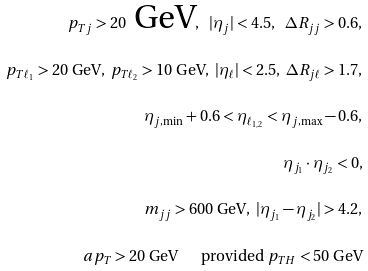<formula> <loc_0><loc_0><loc_500><loc_500>p _ { T j } > 2 0 \text { GeV} , \ | \eta _ { j } | < 4 . 5 , \ \Delta R _ { j j } > 0 . 6 , \\ p _ { T \ell _ { 1 } } > 2 0 \text { GeV} , \ p _ { T \ell _ { 2 } } > 1 0 \text { GeV} , \ | \eta _ { \ell } | < 2 . 5 , \ \Delta R _ { j \ell } > 1 . 7 , \\ \eta _ { j , \min } + 0 . 6 < \eta _ { \ell _ { 1 , 2 } } < \eta _ { j , \max } - 0 . 6 , \\ \eta _ { j _ { 1 } } \cdot \eta _ { j _ { 2 } } < 0 , \\ m _ { j j } > 6 0 0 \text { GeV} , \ | \eta _ { j _ { 1 } } - \eta _ { j _ { 2 } } | > 4 . 2 , \\ \sl a { p } _ { T } > 2 0 \text { GeV } \quad \text { provided } p _ { T H } < 5 0 \text { GeV}</formula> 